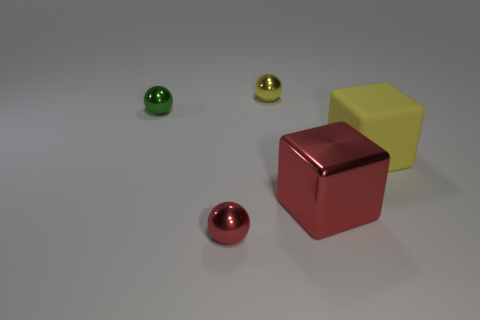Subtract all tiny yellow balls. How many balls are left? 2 Add 3 yellow blocks. How many objects exist? 8 Subtract all yellow balls. How many balls are left? 2 Subtract all spheres. How many objects are left? 2 Subtract 2 cubes. How many cubes are left? 0 Add 4 tiny green things. How many tiny green things are left? 5 Add 3 small gray objects. How many small gray objects exist? 3 Subtract 0 gray spheres. How many objects are left? 5 Subtract all brown balls. Subtract all cyan cubes. How many balls are left? 3 Subtract all big yellow objects. Subtract all tiny yellow rubber blocks. How many objects are left? 4 